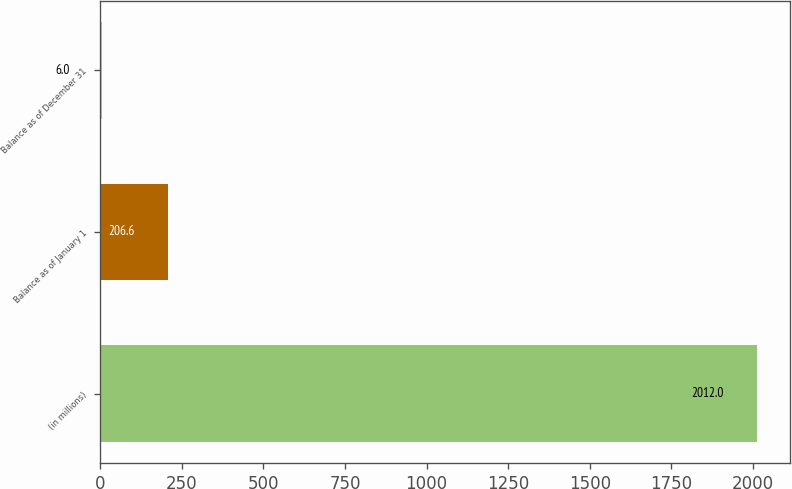Convert chart. <chart><loc_0><loc_0><loc_500><loc_500><bar_chart><fcel>(in millions)<fcel>Balance as of January 1<fcel>Balance as of December 31<nl><fcel>2012<fcel>206.6<fcel>6<nl></chart> 